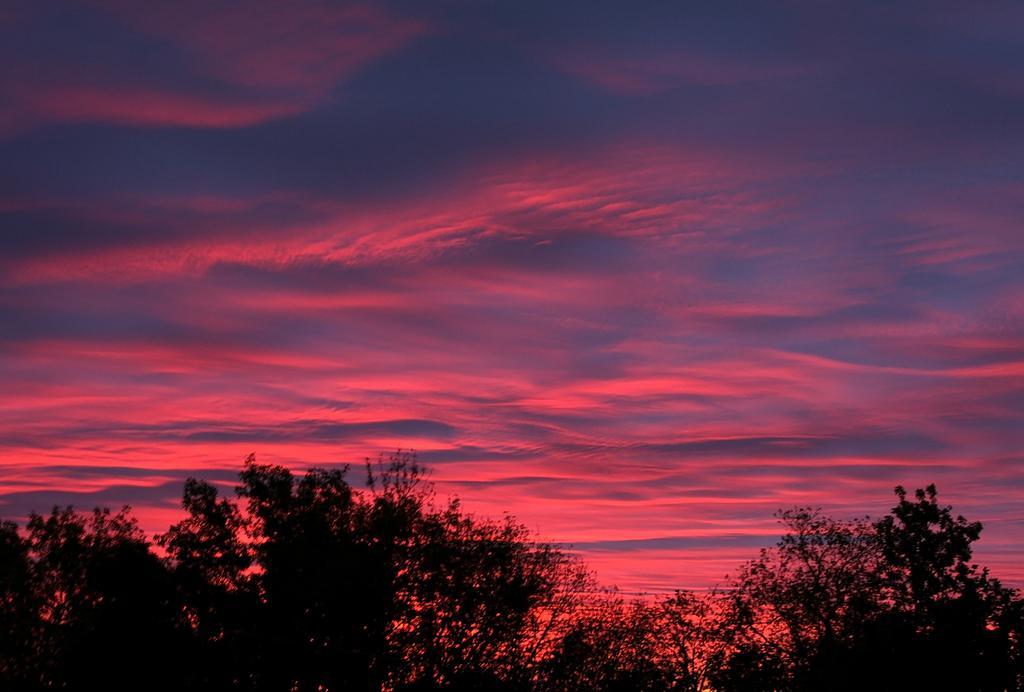Describe this image in one or two sentences. In this image we can see trees and sky with clouds. 